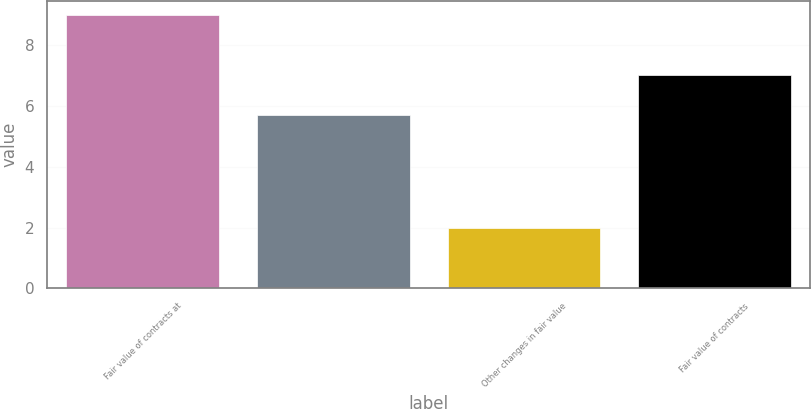<chart> <loc_0><loc_0><loc_500><loc_500><bar_chart><fcel>Fair value of contracts at<fcel>Unnamed: 1<fcel>Other changes in fair value<fcel>Fair value of contracts<nl><fcel>9<fcel>5.7<fcel>2<fcel>7<nl></chart> 